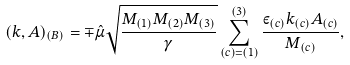<formula> <loc_0><loc_0><loc_500><loc_500>( k , A ) _ { ( B ) } = \mp \hat { \mu } \sqrt { \frac { M _ { ( 1 ) } M _ { ( 2 ) } M _ { ( 3 ) } } { \gamma } } \sum _ { ( c ) = ( 1 ) } ^ { ( 3 ) } \frac { \varepsilon _ { ( c ) } k _ { ( c ) } A _ { ( c ) } } { M _ { ( c ) } } ,</formula> 